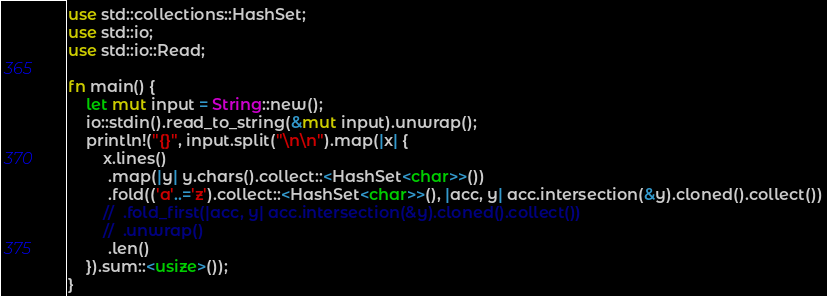Convert code to text. <code><loc_0><loc_0><loc_500><loc_500><_Rust_>use std::collections::HashSet;
use std::io;
use std::io::Read;

fn main() {
    let mut input = String::new();
    io::stdin().read_to_string(&mut input).unwrap();
    println!("{}", input.split("\n\n").map(|x| {
        x.lines()
         .map(|y| y.chars().collect::<HashSet<char>>())
         .fold(('a'..='z').collect::<HashSet<char>>(), |acc, y| acc.intersection(&y).cloned().collect())
        //  .fold_first(|acc, y| acc.intersection(&y).cloned().collect())
        //  .unwrap()
         .len()
    }).sum::<usize>());
}
</code> 